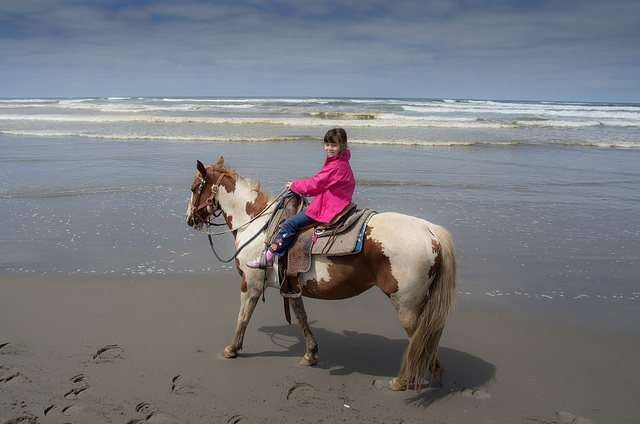Describe the objects in this image and their specific colors. I can see horse in gray, black, maroon, and darkgray tones and people in gray, purple, black, maroon, and brown tones in this image. 